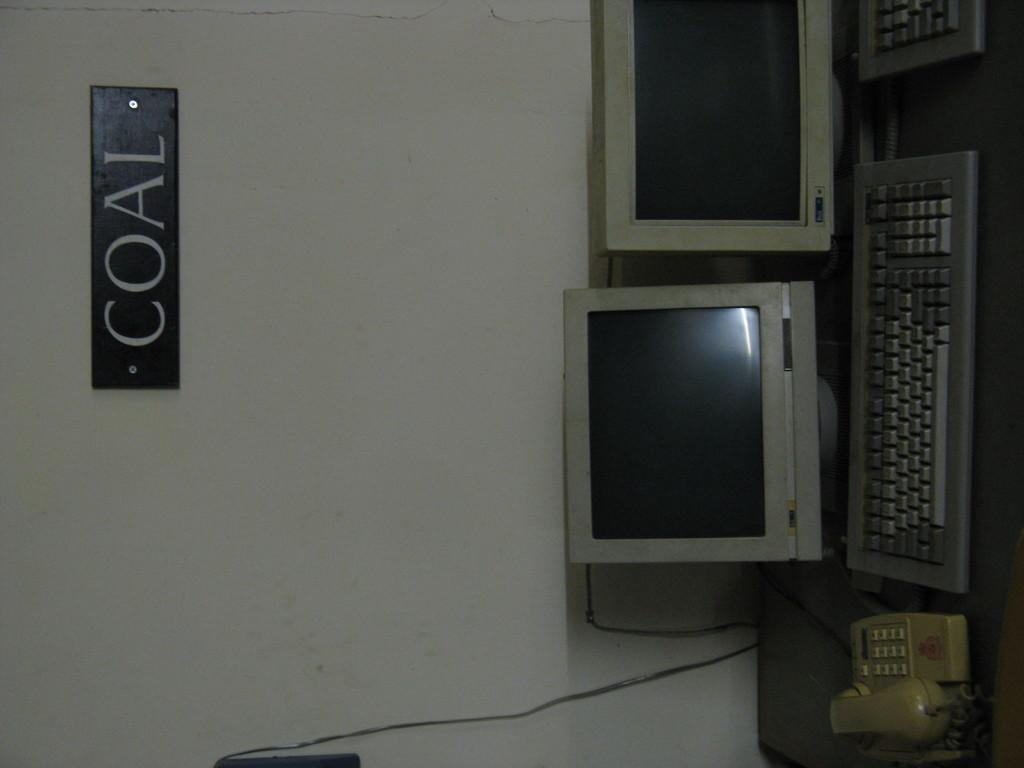Provide a one-sentence caption for the provided image. phone, some monitors and keyboards on a table and sign on wall that says coal. 